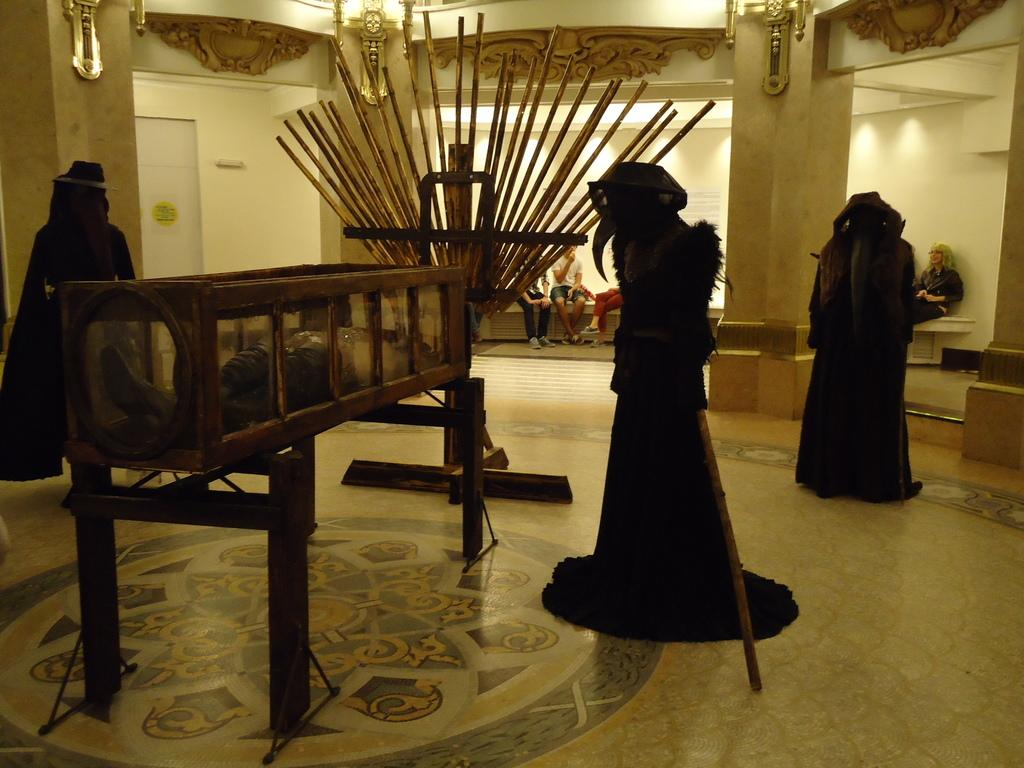How many monuments can be seen in the image? There are 3 monuments in the image. What else is present in the image besides the monuments? There is a box, a wall, people sitting in the background, and lights visible in the image. What type of peace is being promoted by the monuments in the image? The image does not provide any information about the purpose or message of the monuments, so it cannot be determined if they are promoting peace or any other concept. 